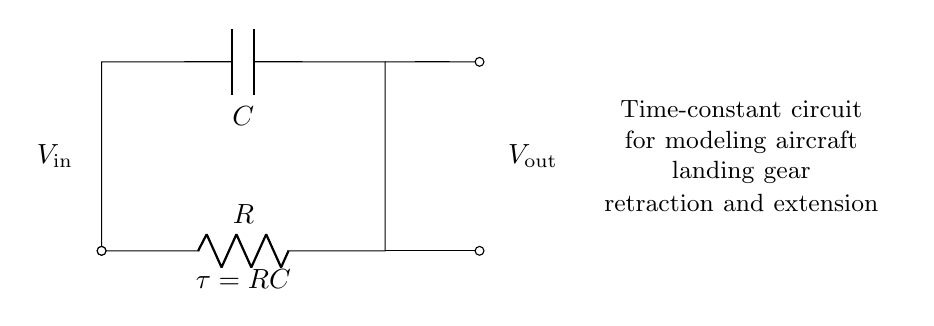What type of circuit is shown? The circuit diagram depicts a resistor-capacitor circuit, which is characterized by the presence of a resistor and a capacitor connected in a specific arrangement for time constant applications.
Answer: Resistor-Capacitor What is the time constant formula for this circuit? The time constant is represented by the equation tau equals R times C, where R is the resistance and C is the capacitance. This relationship describes how quickly the circuit responds to changes in voltage.
Answer: tau equals RC What are the main components in this circuit? The circuit contains two main components: a resistor and a capacitor. These components are essential for the operation of the time constant circuit described.
Answer: Resistor and Capacitor What does Vout represent in the circuit? Vout refers to the output voltage measured across the capacitor in the circuit, indicating how the voltage evolves over time during the charging or discharging process.
Answer: Output voltage How does increasing resistance affect the time constant? Increasing the resistance leads to a higher time constant because tau equals R times C, thus resulting in a slower response of the circuit to voltage changes.
Answer: It increases the time constant What is the effect of capacitance on the circuit behavior? The capacitance value, when increased, also increases the time constant, which causes the capacitor to either charge or discharge more slowly, affecting the operational timing in the landing gear mechanism.
Answer: It increases the time constant 